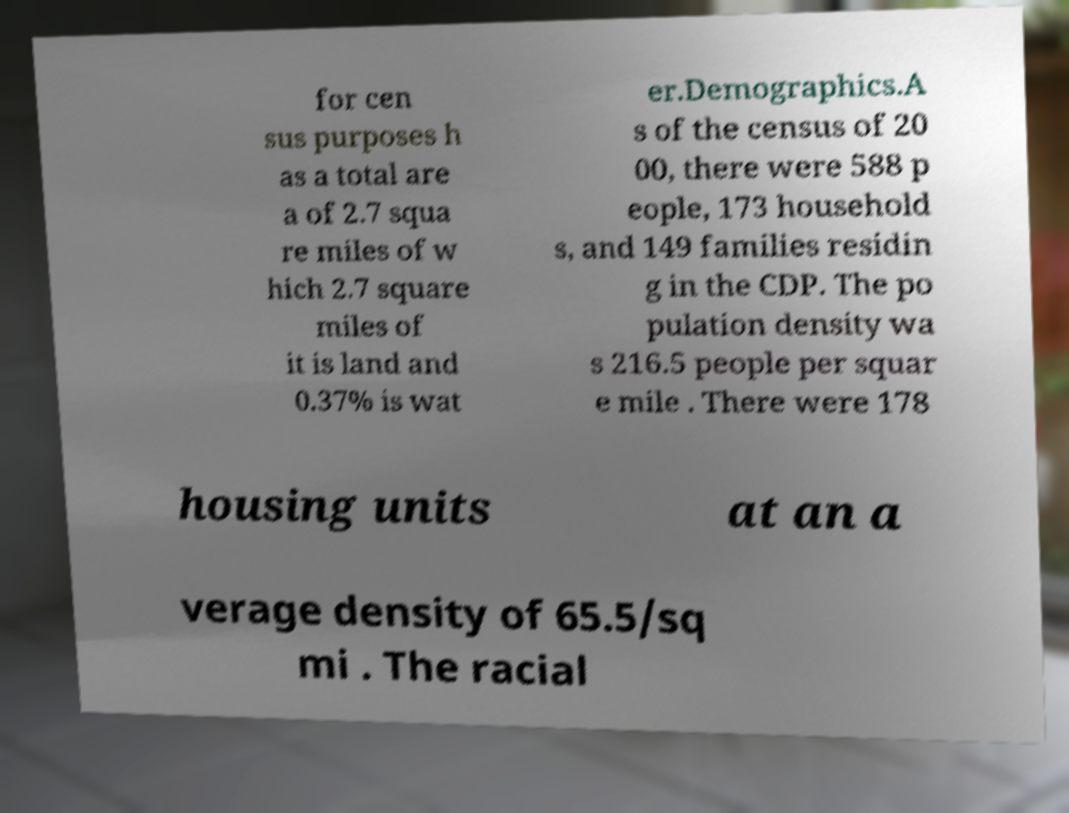Can you read and provide the text displayed in the image?This photo seems to have some interesting text. Can you extract and type it out for me? for cen sus purposes h as a total are a of 2.7 squa re miles of w hich 2.7 square miles of it is land and 0.37% is wat er.Demographics.A s of the census of 20 00, there were 588 p eople, 173 household s, and 149 families residin g in the CDP. The po pulation density wa s 216.5 people per squar e mile . There were 178 housing units at an a verage density of 65.5/sq mi . The racial 